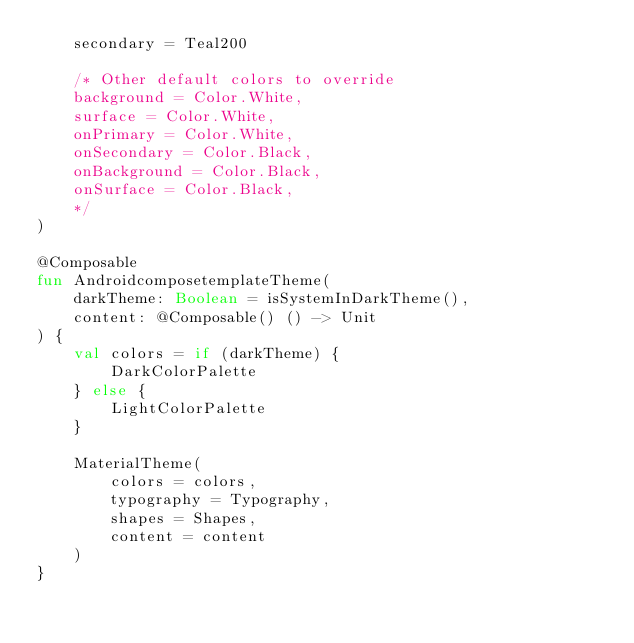Convert code to text. <code><loc_0><loc_0><loc_500><loc_500><_Kotlin_>    secondary = Teal200

    /* Other default colors to override
    background = Color.White,
    surface = Color.White,
    onPrimary = Color.White,
    onSecondary = Color.Black,
    onBackground = Color.Black,
    onSurface = Color.Black,
    */
)

@Composable
fun AndroidcomposetemplateTheme(
    darkTheme: Boolean = isSystemInDarkTheme(),
    content: @Composable() () -> Unit
) {
    val colors = if (darkTheme) {
        DarkColorPalette
    } else {
        LightColorPalette
    }

    MaterialTheme(
        colors = colors,
        typography = Typography,
        shapes = Shapes,
        content = content
    )
}</code> 